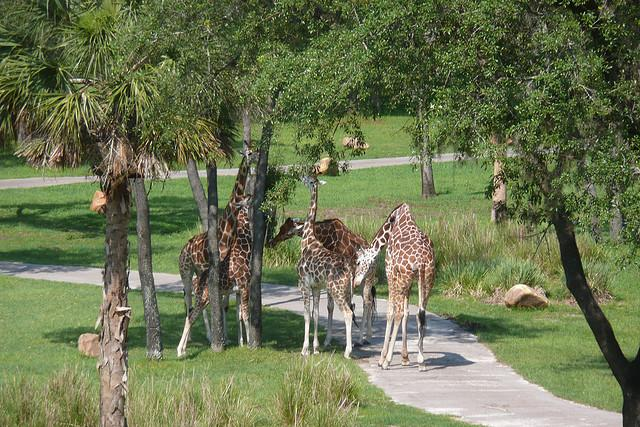What are the giraffes playing around? Please explain your reasoning. trees. Giraffes hang around these to eat the leaves. 